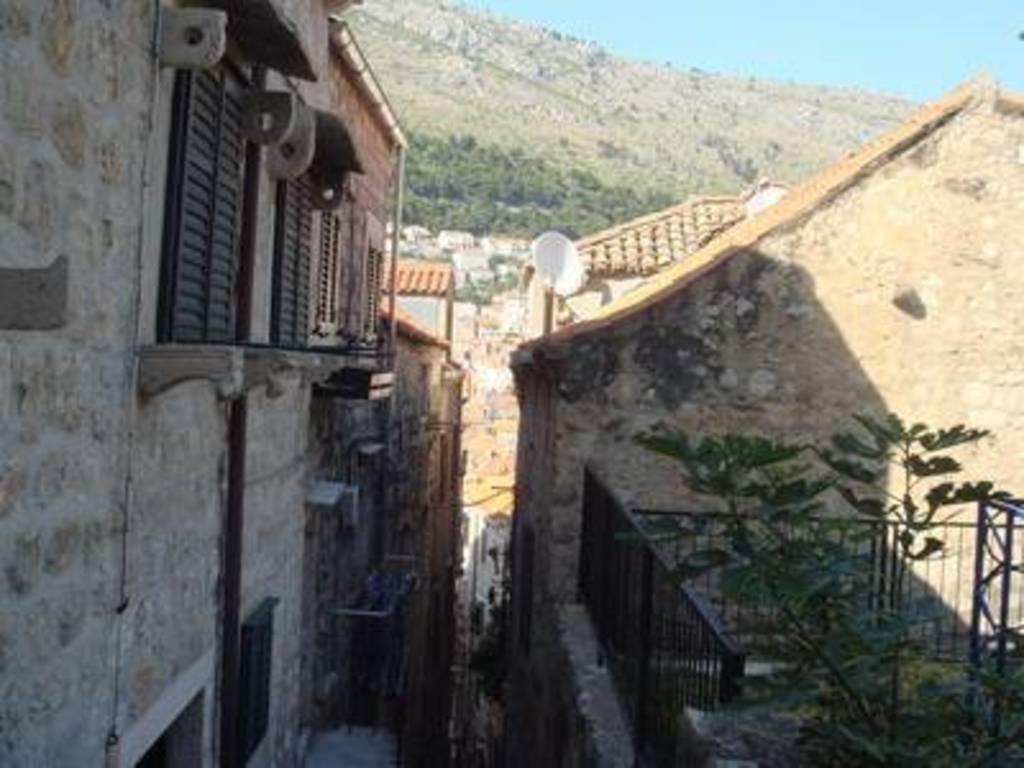How would you summarize this image in a sentence or two? On the right side, we see the plants and a railing. Beside that, we see a building. On the left side, we see the buildings. In the middle, we see the buildings and a satellite dish. There are trees, rocks and hills in the background. In the right top, we see the sky. 